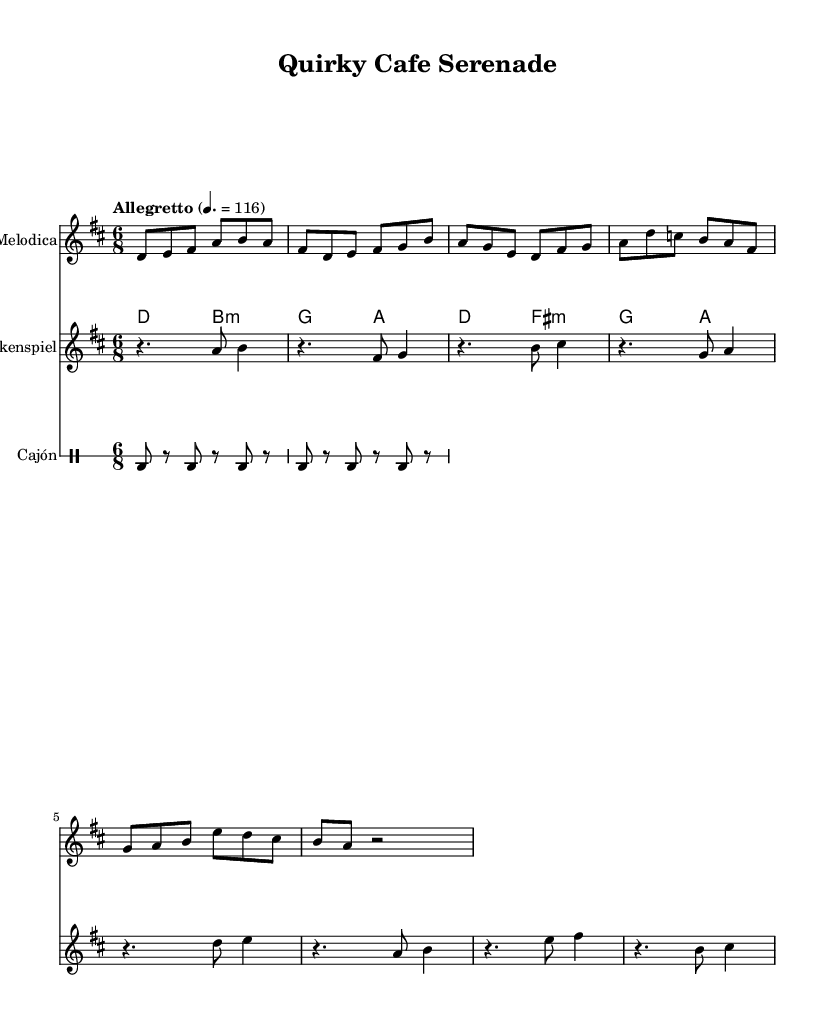What is the key signature of this music? The key signature is D major, indicated by the presence of two sharps (F# and C#).
Answer: D major What is the time signature of this music? The time signature is 6/8, which can be observed at the beginning of the score. This indicates a compound meter with six eighth notes per measure.
Answer: 6/8 What is the tempo marking for this score? The tempo marking "Allegretto" with a metronome marking of 116 indicates a moderately fast tempo. This can be found at the beginning of the score right after the time signature.
Answer: Allegretto Which instrument is playing the melody? The melodica plays the melody, as indicated at the beginning of its staff where it specifically states "Melodica" as the instrument name.
Answer: Melodica How many measures are in the melodica part? The melodica part contains 8 measures, which can be counted from the beginning to the end of its line of music.
Answer: 8 Which instrument has the chord progression in this score? The ukulele part features the chord progression, specifically shown with the chord names above its staff.
Answer: Ukulele What rhythmic pattern does the cajón part consist of? The cajón part features a consistent alternating bass drum pattern that is repeated throughout with a rhythm of "bd r" (bass drum and rest) on eighth note durations.
Answer: Alternating bass pattern 